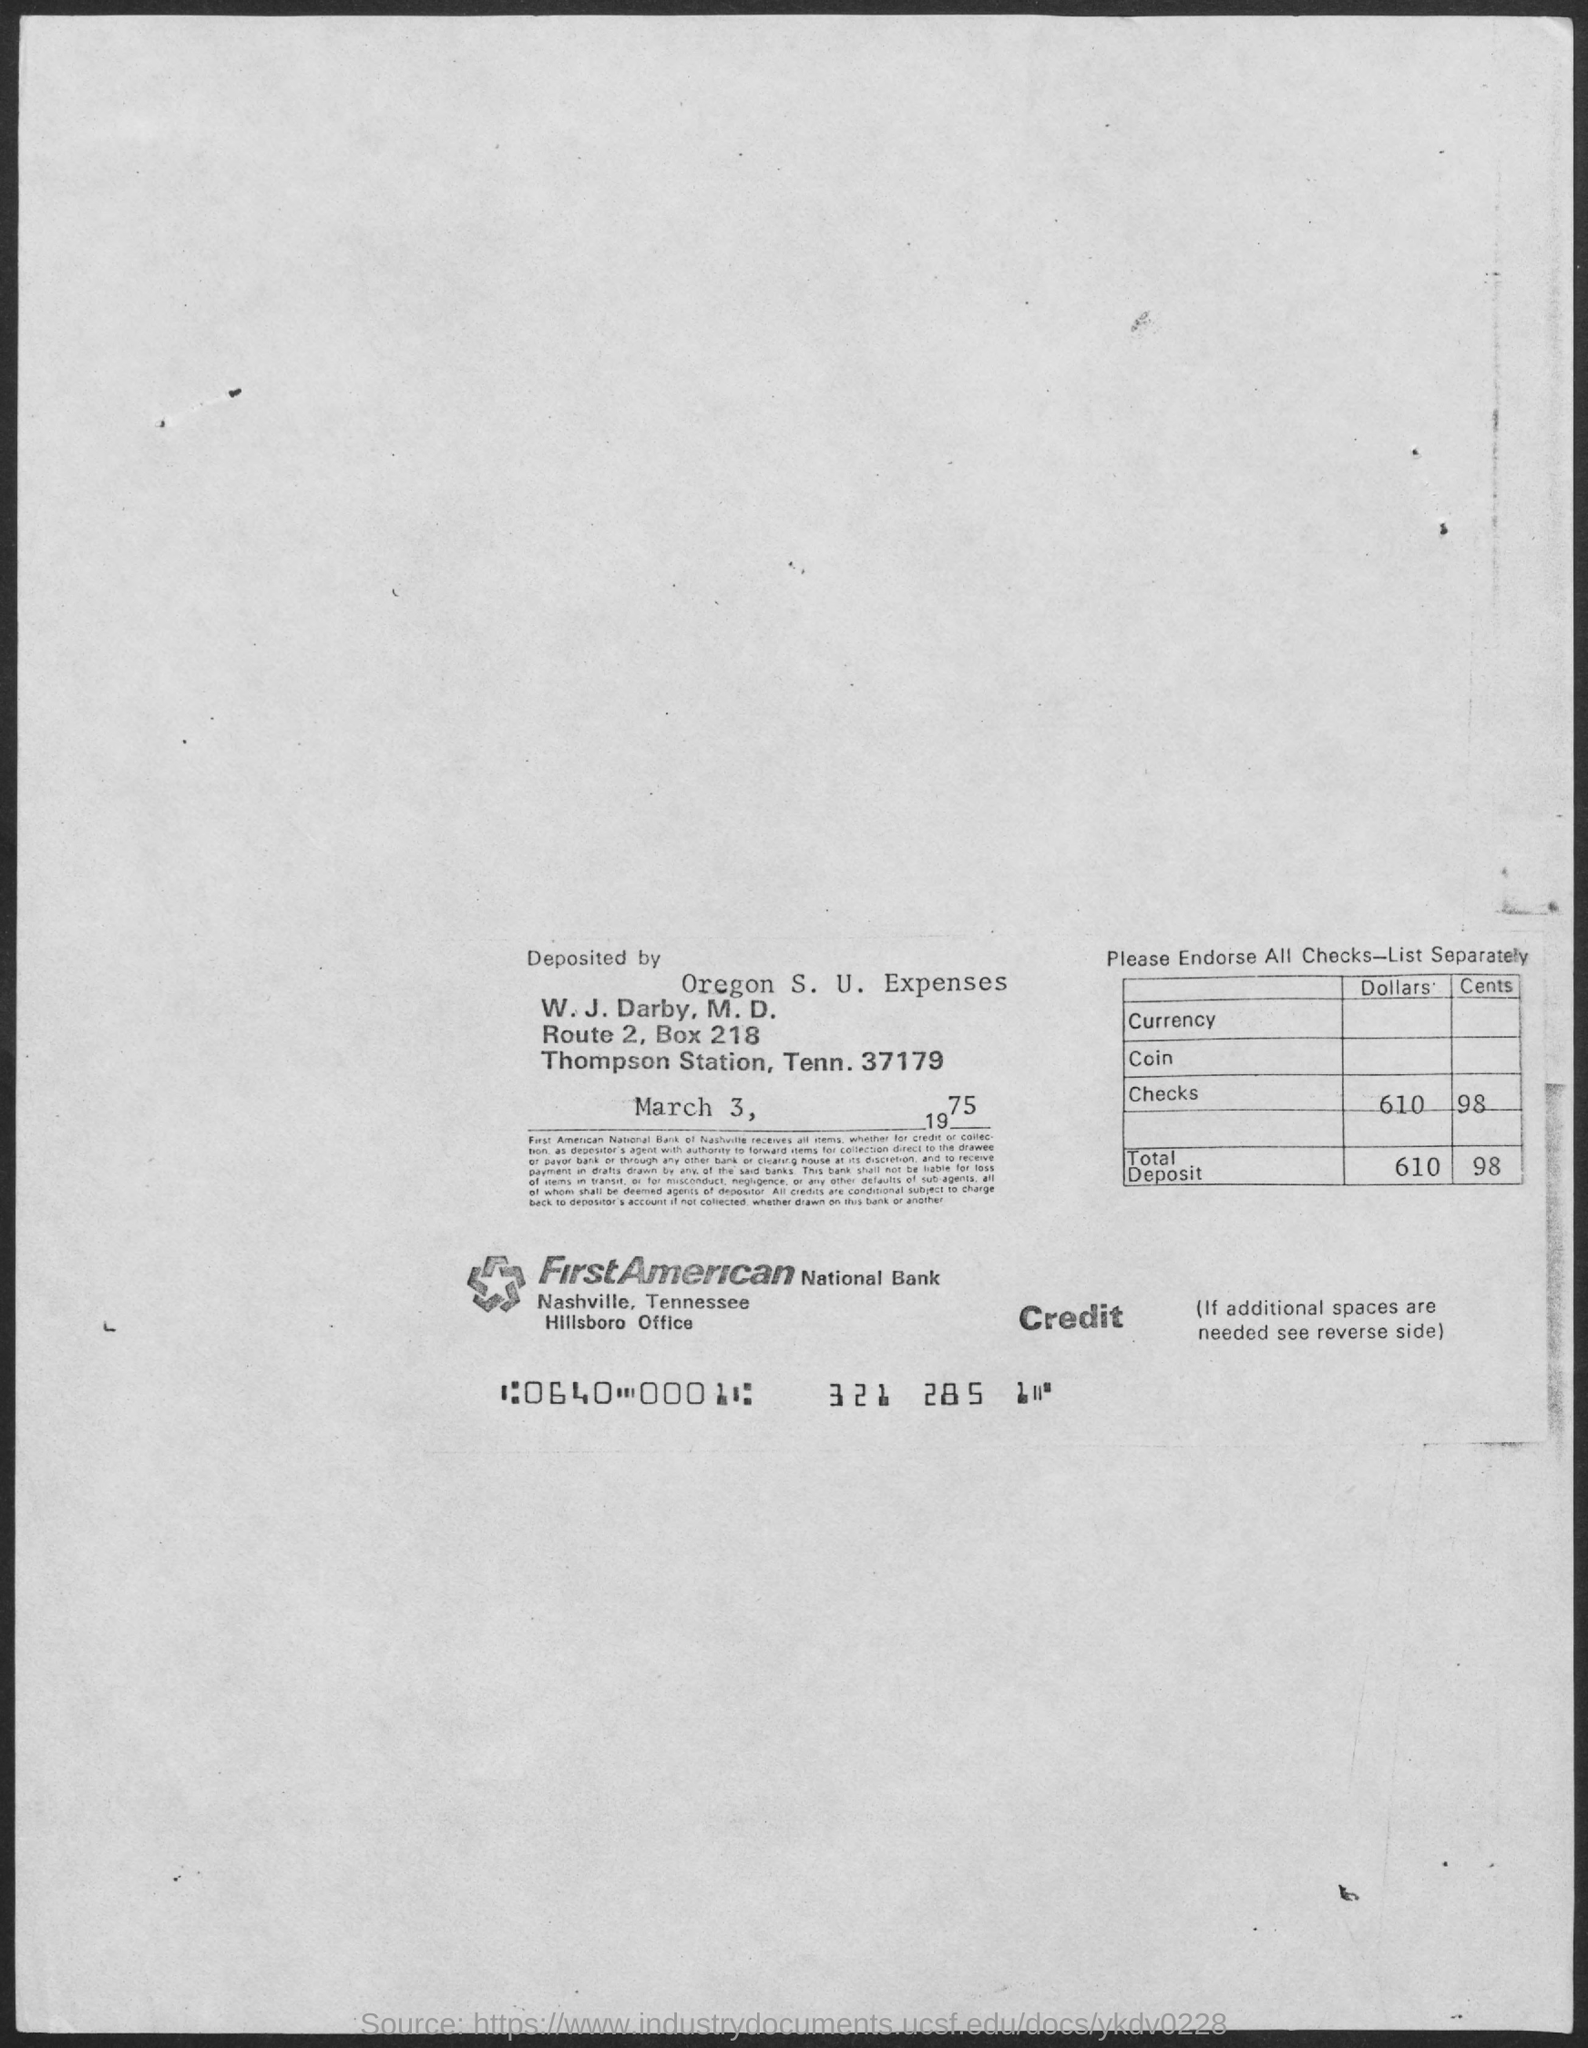Give some essential details in this illustration. The date mentioned in the document is March 3, 1975. 